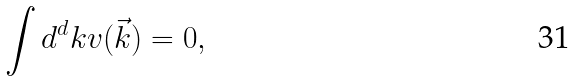<formula> <loc_0><loc_0><loc_500><loc_500>\int d ^ { d } k v ( \vec { k } ) = 0 ,</formula> 